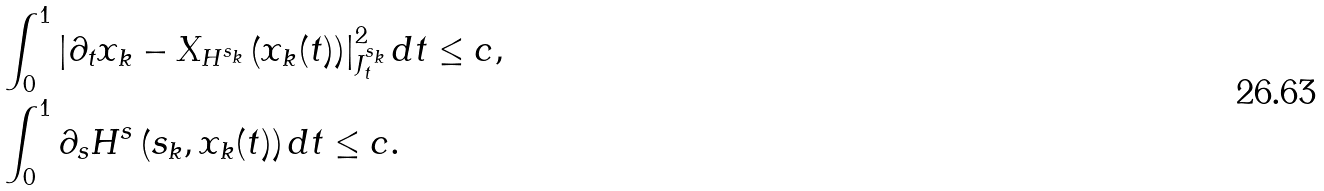<formula> <loc_0><loc_0><loc_500><loc_500>& \int _ { 0 } ^ { 1 } \left | \partial _ { t } x _ { k } - X _ { H ^ { s _ { k } } } \left ( x _ { k } ( t ) \right ) \right | _ { J ^ { s _ { k } } _ { t } } ^ { 2 } d t \leq c , \\ & \int _ { 0 } ^ { 1 } \partial _ { s } H ^ { s } \left ( s _ { k } , x _ { k } ( t ) \right ) d t \leq c .</formula> 